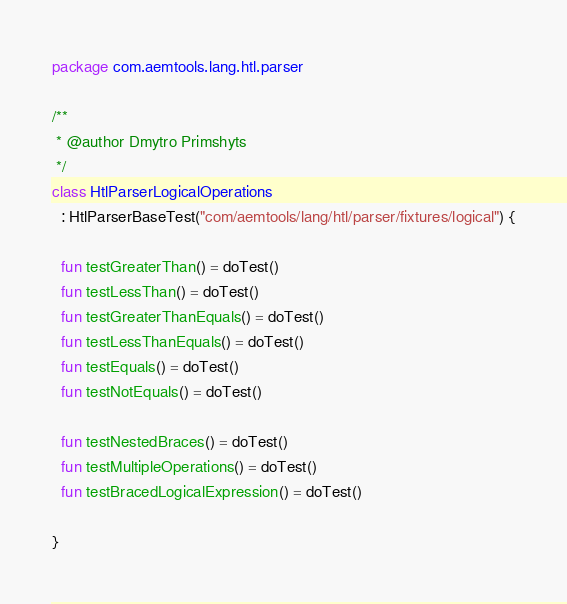<code> <loc_0><loc_0><loc_500><loc_500><_Kotlin_>package com.aemtools.lang.htl.parser

/**
 * @author Dmytro Primshyts
 */
class HtlParserLogicalOperations
  : HtlParserBaseTest("com/aemtools/lang/htl/parser/fixtures/logical") {

  fun testGreaterThan() = doTest()
  fun testLessThan() = doTest()
  fun testGreaterThanEquals() = doTest()
  fun testLessThanEquals() = doTest()
  fun testEquals() = doTest()
  fun testNotEquals() = doTest()

  fun testNestedBraces() = doTest()
  fun testMultipleOperations() = doTest()
  fun testBracedLogicalExpression() = doTest()

}
</code> 